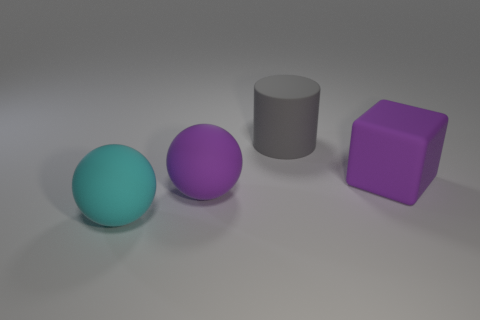Subtract all purple balls. How many balls are left? 1 Subtract 1 blocks. How many blocks are left? 0 Add 2 large red objects. How many objects exist? 6 Subtract all red cubes. How many purple cylinders are left? 0 Add 2 big purple matte spheres. How many big purple matte spheres are left? 3 Add 1 tiny purple rubber blocks. How many tiny purple rubber blocks exist? 1 Subtract 0 brown cylinders. How many objects are left? 4 Subtract all green balls. Subtract all green blocks. How many balls are left? 2 Subtract all large blue cubes. Subtract all rubber cylinders. How many objects are left? 3 